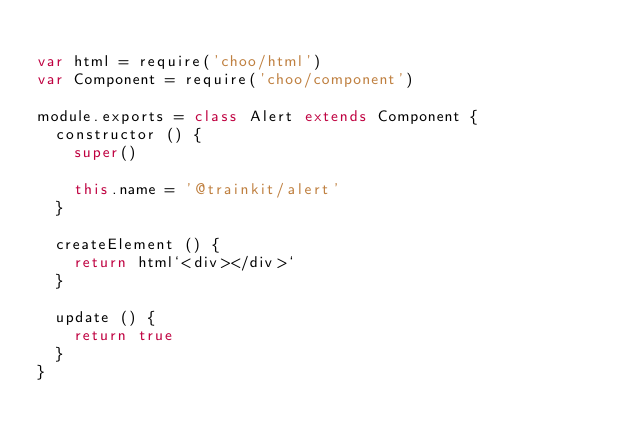Convert code to text. <code><loc_0><loc_0><loc_500><loc_500><_JavaScript_>
var html = require('choo/html')
var Component = require('choo/component')

module.exports = class Alert extends Component {
  constructor () {
    super()

    this.name = '@trainkit/alert'
  }

  createElement () {
    return html`<div></div>`
  }

  update () {
    return true
  }
}</code> 